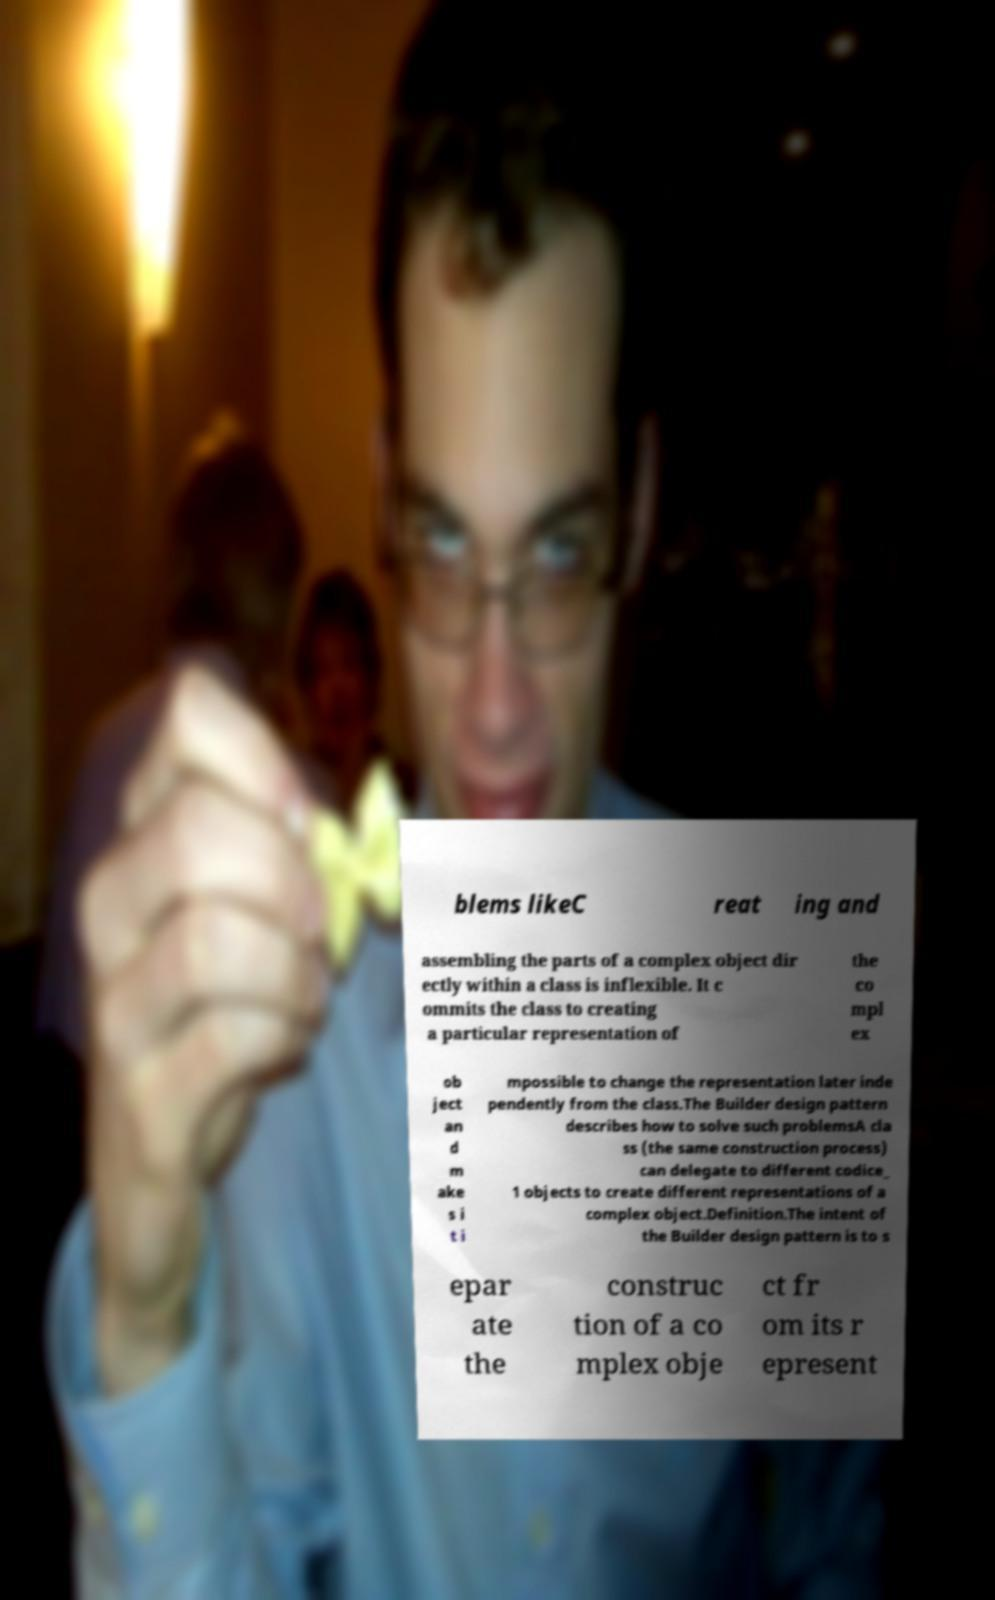Could you assist in decoding the text presented in this image and type it out clearly? blems likeC reat ing and assembling the parts of a complex object dir ectly within a class is inflexible. It c ommits the class to creating a particular representation of the co mpl ex ob ject an d m ake s i t i mpossible to change the representation later inde pendently from the class.The Builder design pattern describes how to solve such problemsA cla ss (the same construction process) can delegate to different codice_ 1 objects to create different representations of a complex object.Definition.The intent of the Builder design pattern is to s epar ate the construc tion of a co mplex obje ct fr om its r epresent 